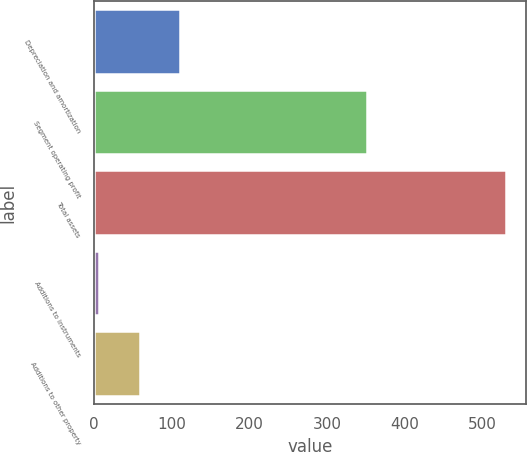Convert chart to OTSL. <chart><loc_0><loc_0><loc_500><loc_500><bar_chart><fcel>Depreciation and amortization<fcel>Segment operating profit<fcel>Total assets<fcel>Additions to instruments<fcel>Additions to other property<nl><fcel>110.86<fcel>351<fcel>530.3<fcel>6<fcel>58.43<nl></chart> 